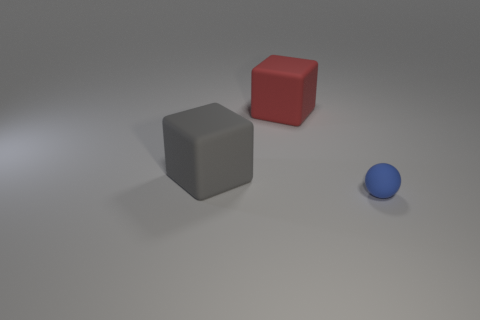There is a large matte cube that is to the left of the red block; are there any things that are to the right of it?
Provide a short and direct response. Yes. What number of other matte spheres are the same color as the small rubber sphere?
Ensure brevity in your answer.  0. Are the blue thing and the big gray thing made of the same material?
Your answer should be very brief. Yes. Are there any gray cubes in front of the large red thing?
Provide a short and direct response. Yes. There is a block to the right of the large thing that is in front of the big red matte cube; what is its material?
Ensure brevity in your answer.  Rubber. There is a red object that is the same shape as the gray matte thing; what size is it?
Make the answer very short. Large. There is a matte object that is both on the left side of the small blue ball and right of the big gray rubber thing; what color is it?
Provide a succinct answer. Red. Does the object that is right of the red object have the same size as the big red matte object?
Provide a succinct answer. No. Are there any other things that are the same shape as the tiny rubber object?
Offer a terse response. No. Is the material of the gray thing the same as the cube behind the gray thing?
Ensure brevity in your answer.  Yes. 